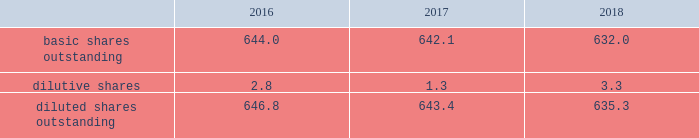2018 emerson annual report | 37 inco me taxes the provision for income taxes is based on pretax income reported in the consolidated statements of earnings and tax rates currently enacted in each jurisdiction .
Certain income and expense items are recognized in different time periods for financial reporting and income tax filing purposes , and deferred income taxes are provided for the effect of temporary differences .
The company also provides for foreign withholding taxes and any applicable u.s .
Income taxes on earnings intended to be repatriated from non-u.s .
Locations .
No provision has been made for these taxes on approximately $ 3.4 billion of undistributed earnings of non-u.s .
Subsidiaries as of september 30 , 2018 , as these earnings are considered indefinitely invested or otherwise retained for continuing international operations .
Recognition of foreign withholding taxes and any applicable u.s .
Income taxes on undistributed non-u.s .
Earnings would be triggered by a management decision to repatriate those earnings .
Determination of the amount of taxes that might be paid on these undistributed earnings if eventually remitted is not practicable .
See note 14 .
( 2 ) weighted-average common shares basic earnings per common share consider only the weighted-average of common shares outstanding while diluted earnings per common share also consider the dilutive effects of stock options and incentive shares .
An inconsequential number of shares of common stock were excluded from the computation of dilutive earnings per in 2018 as the effect would have been antidilutive , while 4.5 million and 13.3 million shares of common stock were excluded in 2017 and 2016 , respectively .
Earnings allocated to participating securities were inconsequential for all years presented .
Reconciliations of weighted-average shares for basic and diluted earnings per common share follow ( shares in millions ) : 2016 2017 2018 .
( 3 ) acquisitions and divestitures on july 17 , 2018 , the company completed the acquisition of aventics , a global provider of smart pneumatics technologies that power machine and factory automation applications , for $ 622 , net of cash acquired .
This business , which has annual sales of approximately $ 425 , is reported in the industrial solutions product offering in the automation solutions segment .
The company recognized goodwill of $ 358 ( $ 20 of which is expected to be tax deductible ) , and identifiable intangible assets of $ 278 , primarily intellectual property and customer relationships with a weighted-average useful life of approximately 12 years .
On july 2 , 2018 , the company completed the acquisition of textron 2019s tools and test equipment business for $ 810 , net of cash acquired .
This business , with annual sales of approximately $ 470 , is a manufacturer of electrical and utility tools , diagnostics , and test and measurement instruments , and is reported in the tools & home products segment .
The company recognized goodwill of $ 374 ( $ 17 of which is expected to be tax deductible ) , and identifiable intangible assets of $ 358 , primarily intellectual property and customer relationships with a weighted-average useful life of approximately 14 years .
On december 1 , 2017 , the company acquired paradigm , a provider of software solutions for the oil and gas industry , for $ 505 , net of cash acquired .
This business had annual sales of approximately $ 140 and is included in the measurement & analytical instrumentation product offering within automation solutions .
The company recognized goodwill of $ 328 ( $ 160 of which is expected to be tax deductible ) , and identifiable intangible assets of $ 238 , primarily intellectual property and customer relationships with a weighted-average useful life of approximately 11 years .
During 2018 , the company also acquired four smaller businesses , two in the automation solutions segment and two in the climate technologies segment. .
For the aventics acquisition what was the ratio of price paid to annual sales? 
Rationale: this is a standard valuation measure and can point out if the price was in line .
Computations: (622 / 425)
Answer: 1.46353. 